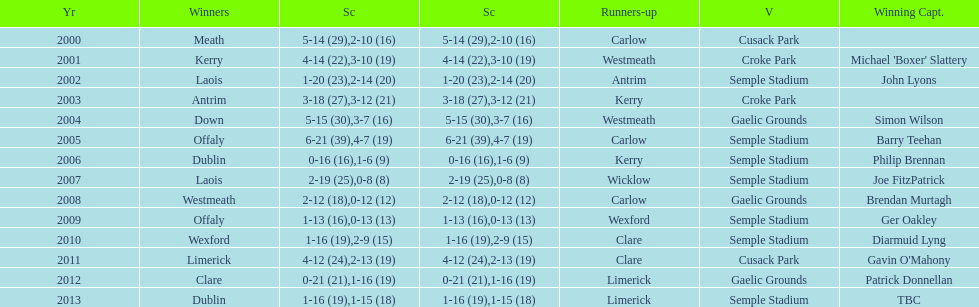How many times was carlow the runner-up? 3. 